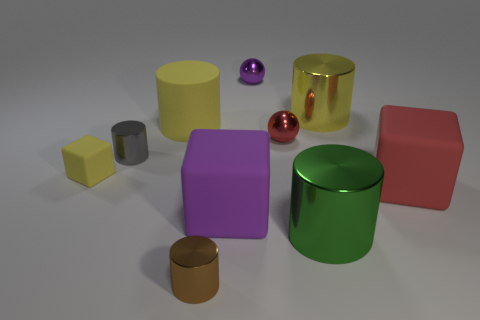There is a yellow matte thing that is behind the small gray metallic object; is its shape the same as the tiny red object?
Ensure brevity in your answer.  No. Is the number of small cylinders in front of the purple ball less than the number of tiny gray metal objects that are on the left side of the tiny gray shiny cylinder?
Your response must be concise. No. What is the purple object that is behind the red rubber thing made of?
Make the answer very short. Metal. What size is the matte block that is the same color as the matte cylinder?
Offer a terse response. Small. Is there a brown metallic thing of the same size as the brown cylinder?
Make the answer very short. No. Does the small red object have the same shape as the big object left of the brown cylinder?
Your response must be concise. No. Does the cube on the left side of the large purple cube have the same size as the yellow cylinder that is to the right of the large purple block?
Your answer should be very brief. No. How many other objects are there of the same shape as the tiny yellow object?
Make the answer very short. 2. What is the material of the yellow cylinder that is on the left side of the big matte block that is in front of the big red object?
Your answer should be compact. Rubber. What number of metal objects are either small red objects or balls?
Provide a short and direct response. 2. 